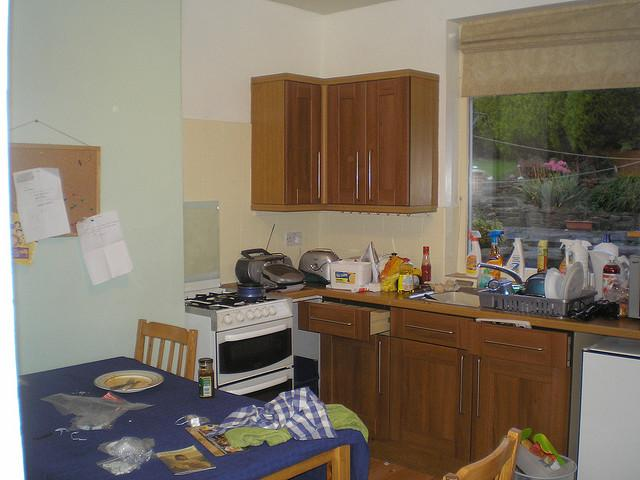What is the object with the metal rod on it? Please explain your reasoning. radio. The object is a radio. 